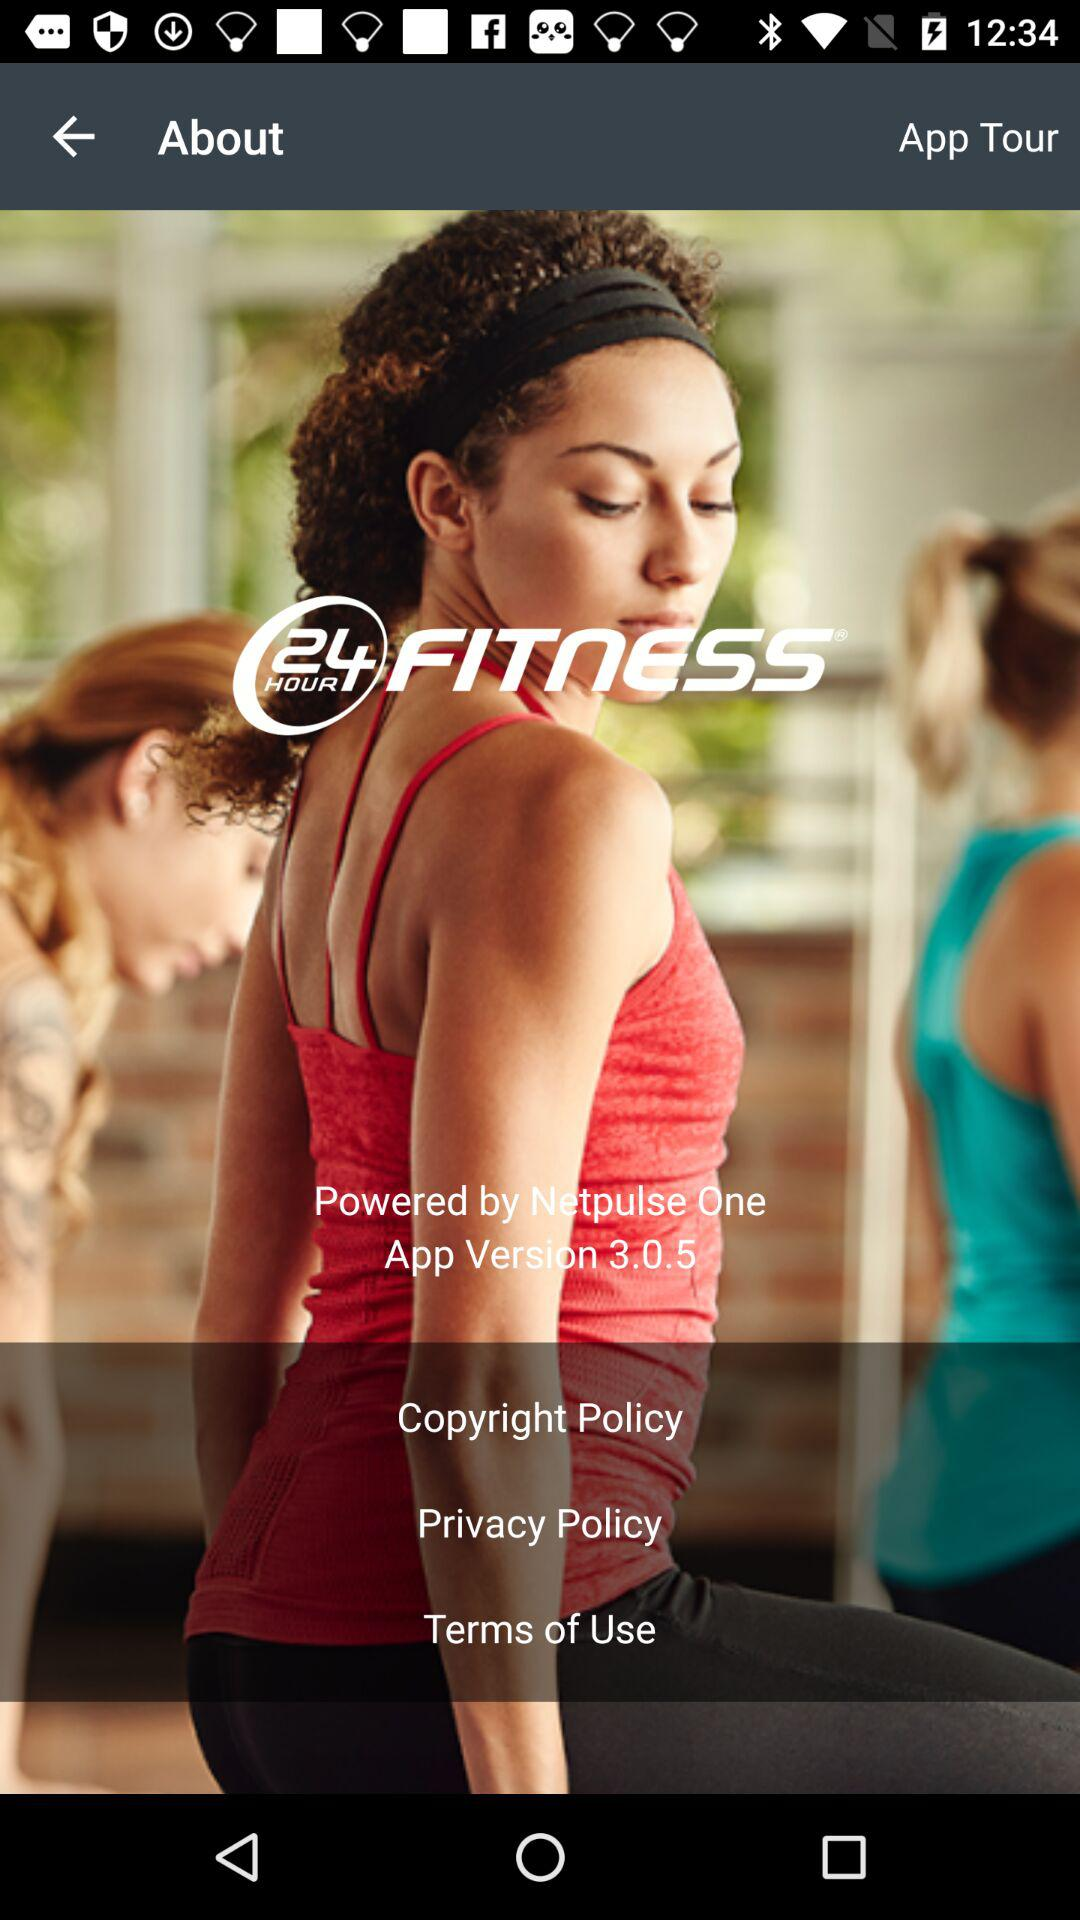What is the version? The version is 3.0.5. 